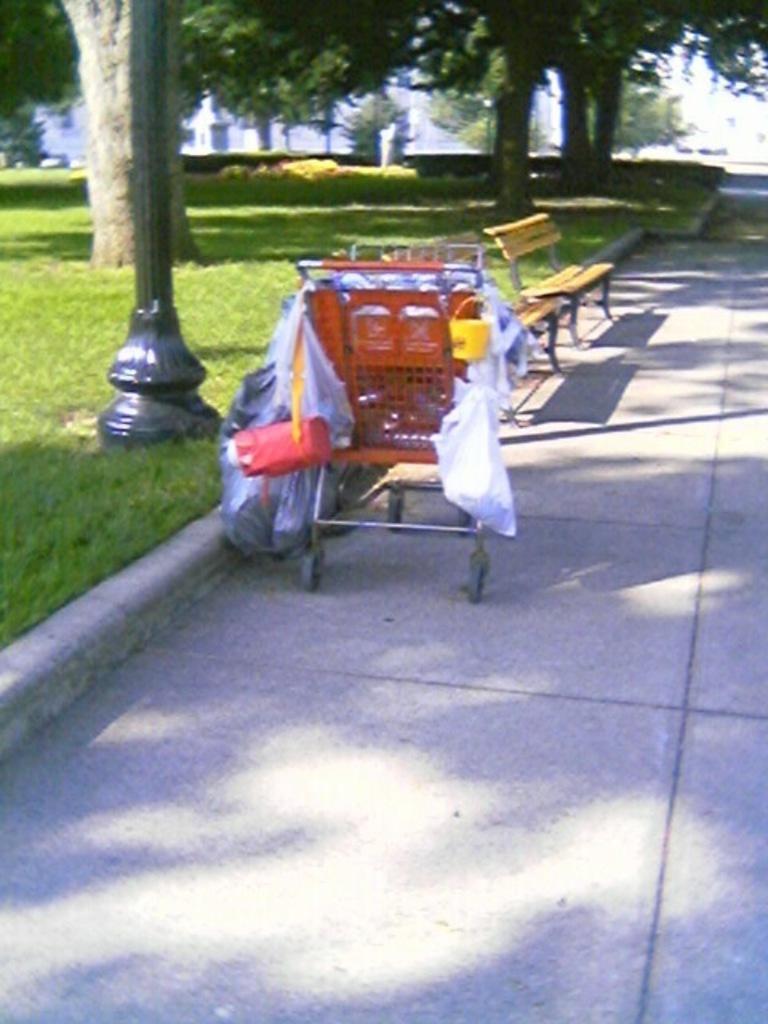In one or two sentences, can you explain what this image depicts? In this image we can see trolleys, benches. At the bottom of the image there is floor. In the background of the image there are trees. There is grass to the left side of the image. 